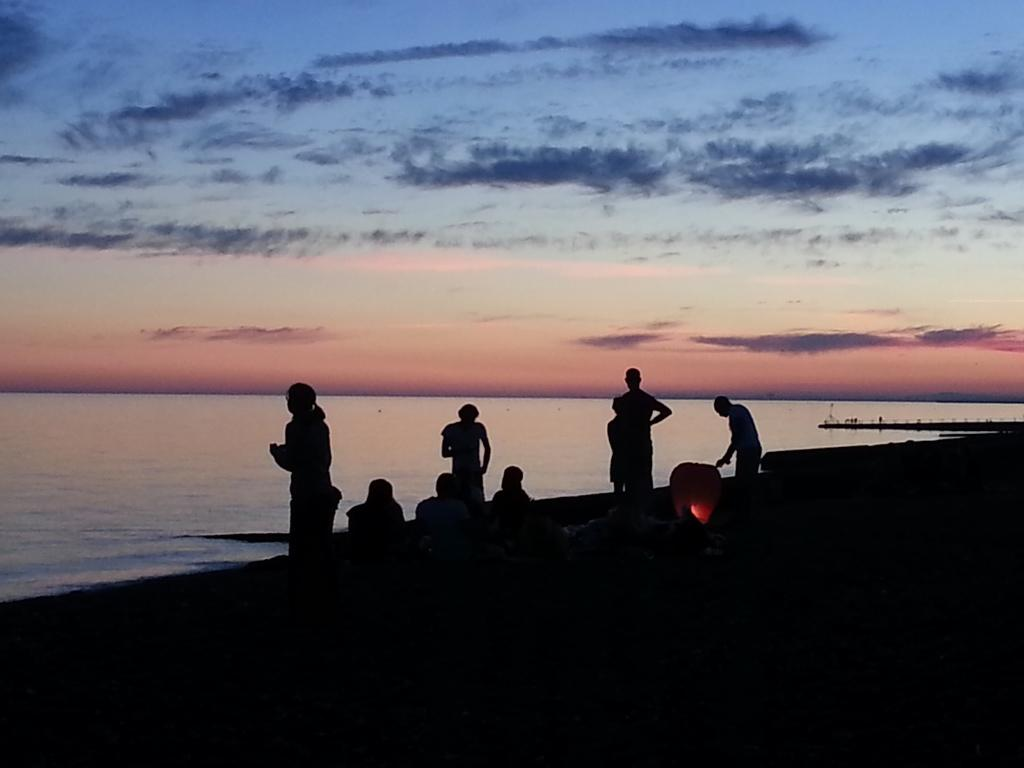What can be seen in the foreground of the image? There are people and a lantern in the foreground of the image. What is the lighting condition at the bottom of the image? The bottom of the image appears to be dark. What is visible in the background of the image? Water and the sky are visible in the background of the image. What type of milk is being consumed by the people in the image? There is no milk present in the image, and it is not mentioned that the people are consuming anything. How does the poison affect the throat of the people in the image? There is no mention of poison or any negative effects on the people in the image. 